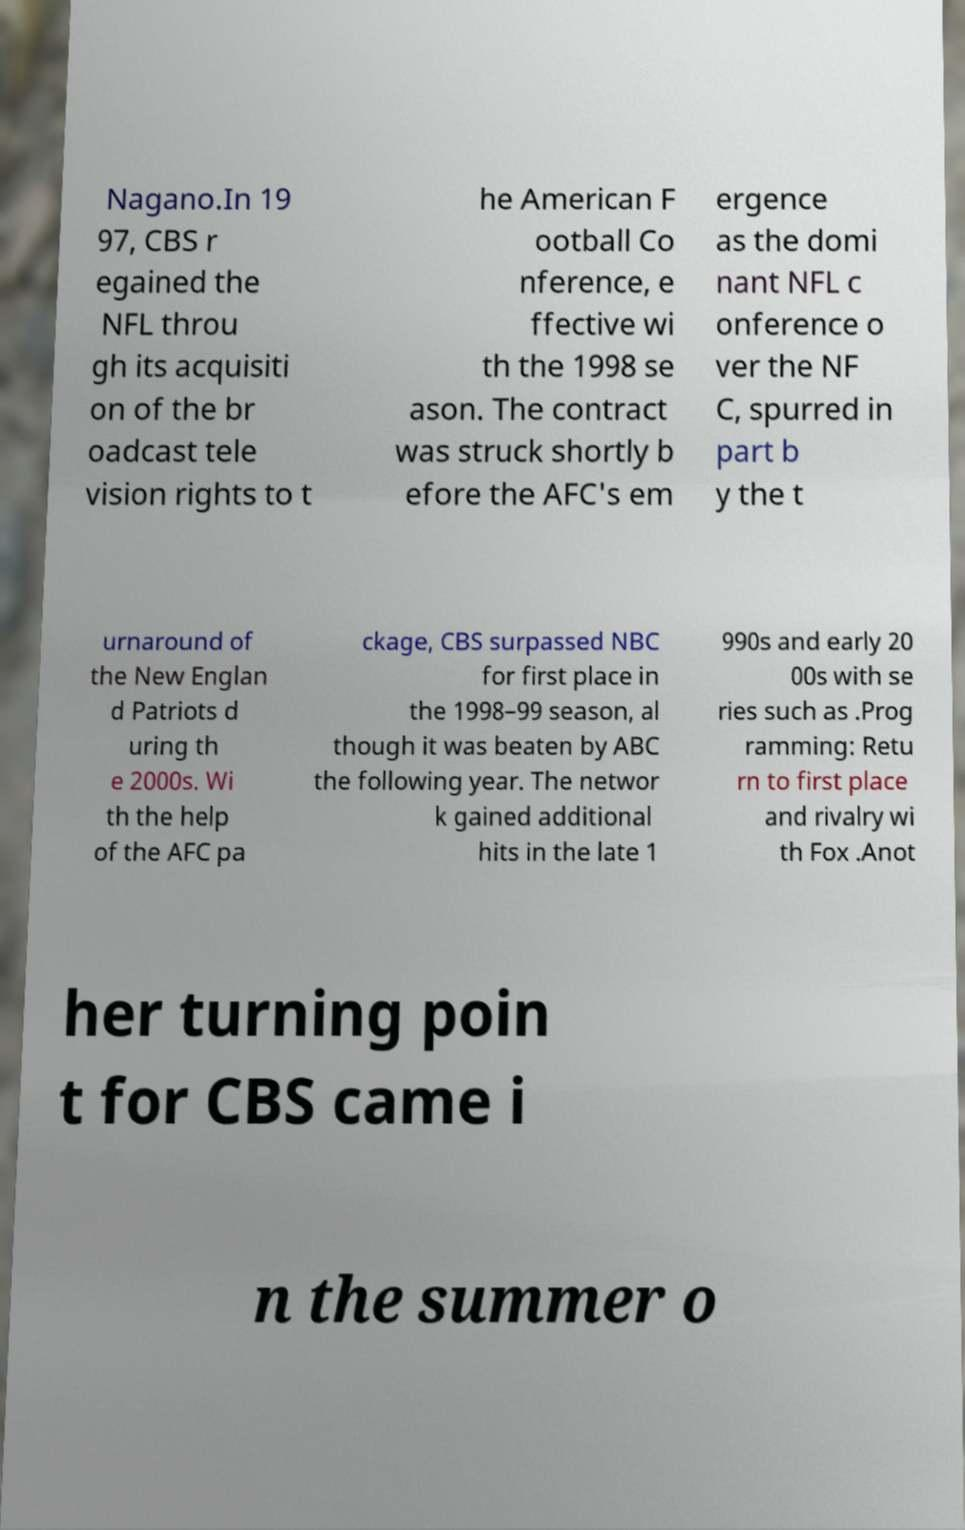Please identify and transcribe the text found in this image. Nagano.In 19 97, CBS r egained the NFL throu gh its acquisiti on of the br oadcast tele vision rights to t he American F ootball Co nference, e ffective wi th the 1998 se ason. The contract was struck shortly b efore the AFC's em ergence as the domi nant NFL c onference o ver the NF C, spurred in part b y the t urnaround of the New Englan d Patriots d uring th e 2000s. Wi th the help of the AFC pa ckage, CBS surpassed NBC for first place in the 1998–99 season, al though it was beaten by ABC the following year. The networ k gained additional hits in the late 1 990s and early 20 00s with se ries such as .Prog ramming: Retu rn to first place and rivalry wi th Fox .Anot her turning poin t for CBS came i n the summer o 